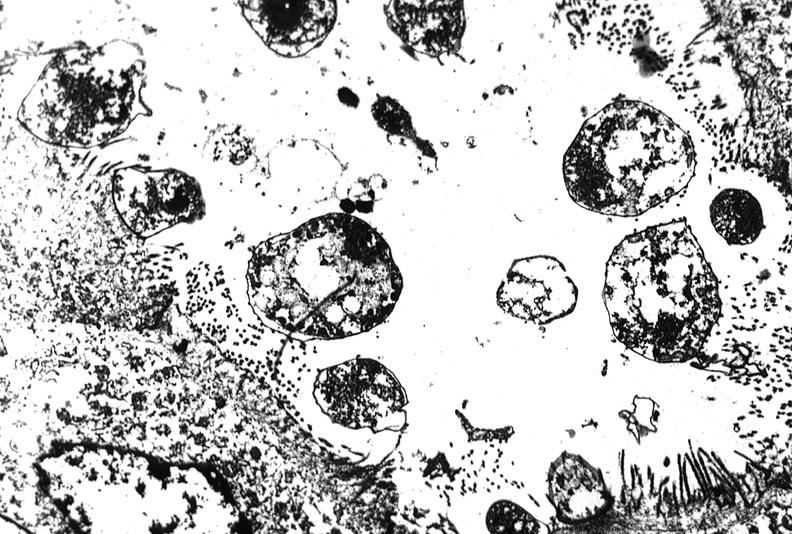s nodular tumor present?
Answer the question using a single word or phrase. No 